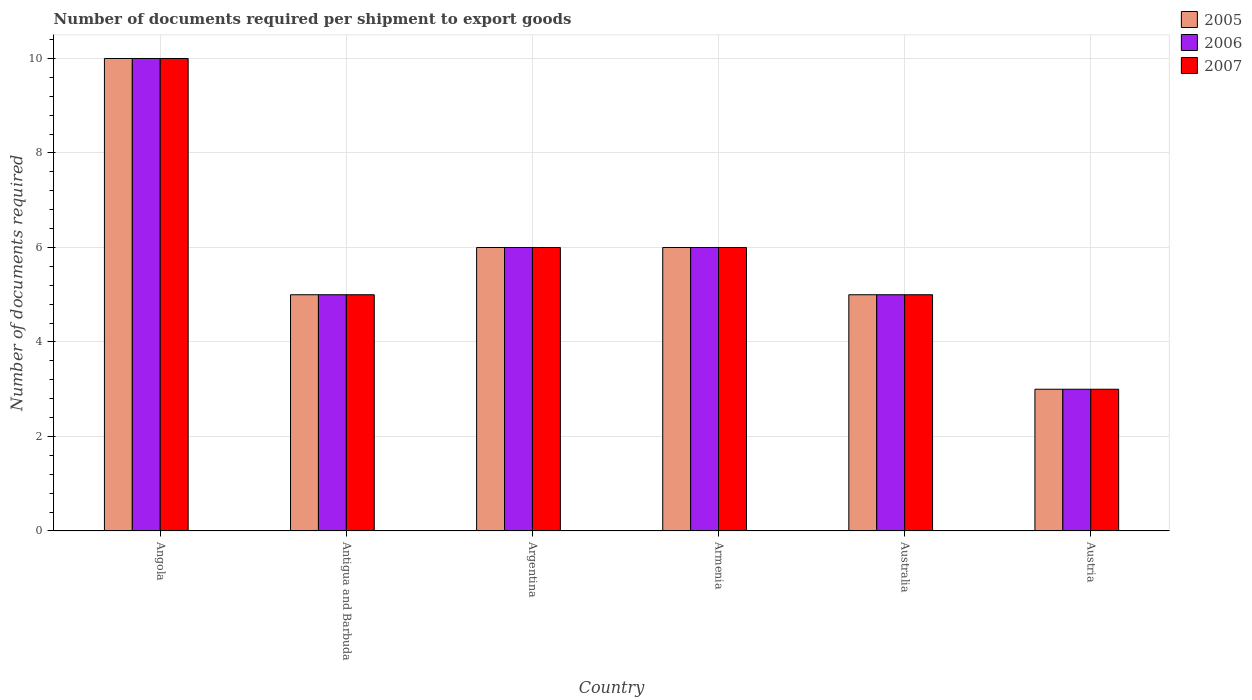How many different coloured bars are there?
Give a very brief answer. 3. How many groups of bars are there?
Keep it short and to the point. 6. Are the number of bars per tick equal to the number of legend labels?
Your answer should be very brief. Yes. What is the number of documents required per shipment to export goods in 2007 in Antigua and Barbuda?
Make the answer very short. 5. Across all countries, what is the maximum number of documents required per shipment to export goods in 2007?
Ensure brevity in your answer.  10. Across all countries, what is the minimum number of documents required per shipment to export goods in 2006?
Keep it short and to the point. 3. In which country was the number of documents required per shipment to export goods in 2006 maximum?
Keep it short and to the point. Angola. What is the average number of documents required per shipment to export goods in 2006 per country?
Ensure brevity in your answer.  5.83. What is the ratio of the number of documents required per shipment to export goods in 2005 in Antigua and Barbuda to that in Austria?
Provide a short and direct response. 1.67. What is the difference between the highest and the second highest number of documents required per shipment to export goods in 2005?
Provide a short and direct response. 4. In how many countries, is the number of documents required per shipment to export goods in 2005 greater than the average number of documents required per shipment to export goods in 2005 taken over all countries?
Your response must be concise. 3. Is the sum of the number of documents required per shipment to export goods in 2007 in Australia and Austria greater than the maximum number of documents required per shipment to export goods in 2005 across all countries?
Your response must be concise. No. What does the 3rd bar from the left in Austria represents?
Your answer should be very brief. 2007. What does the 1st bar from the right in Australia represents?
Your answer should be very brief. 2007. Is it the case that in every country, the sum of the number of documents required per shipment to export goods in 2005 and number of documents required per shipment to export goods in 2007 is greater than the number of documents required per shipment to export goods in 2006?
Offer a very short reply. Yes. How many countries are there in the graph?
Provide a short and direct response. 6. What is the difference between two consecutive major ticks on the Y-axis?
Keep it short and to the point. 2. Does the graph contain any zero values?
Your response must be concise. No. What is the title of the graph?
Offer a very short reply. Number of documents required per shipment to export goods. What is the label or title of the X-axis?
Provide a succinct answer. Country. What is the label or title of the Y-axis?
Your answer should be compact. Number of documents required. What is the Number of documents required of 2007 in Angola?
Provide a short and direct response. 10. What is the Number of documents required in 2005 in Antigua and Barbuda?
Make the answer very short. 5. What is the Number of documents required of 2007 in Antigua and Barbuda?
Your answer should be compact. 5. What is the Number of documents required in 2005 in Argentina?
Make the answer very short. 6. What is the Number of documents required of 2006 in Argentina?
Provide a short and direct response. 6. What is the Number of documents required in 2007 in Argentina?
Make the answer very short. 6. What is the Number of documents required in 2006 in Armenia?
Make the answer very short. 6. What is the Number of documents required of 2007 in Armenia?
Offer a terse response. 6. What is the Number of documents required of 2005 in Australia?
Your response must be concise. 5. What is the Number of documents required of 2007 in Australia?
Give a very brief answer. 5. What is the Number of documents required of 2005 in Austria?
Provide a succinct answer. 3. What is the Number of documents required of 2006 in Austria?
Your answer should be compact. 3. Across all countries, what is the maximum Number of documents required in 2006?
Make the answer very short. 10. Across all countries, what is the minimum Number of documents required in 2007?
Provide a succinct answer. 3. What is the total Number of documents required of 2007 in the graph?
Your response must be concise. 35. What is the difference between the Number of documents required in 2005 in Angola and that in Antigua and Barbuda?
Keep it short and to the point. 5. What is the difference between the Number of documents required of 2006 in Angola and that in Antigua and Barbuda?
Keep it short and to the point. 5. What is the difference between the Number of documents required of 2007 in Angola and that in Antigua and Barbuda?
Your answer should be compact. 5. What is the difference between the Number of documents required of 2005 in Angola and that in Argentina?
Offer a terse response. 4. What is the difference between the Number of documents required in 2006 in Angola and that in Argentina?
Keep it short and to the point. 4. What is the difference between the Number of documents required in 2007 in Angola and that in Armenia?
Provide a short and direct response. 4. What is the difference between the Number of documents required of 2007 in Angola and that in Australia?
Provide a succinct answer. 5. What is the difference between the Number of documents required in 2006 in Angola and that in Austria?
Ensure brevity in your answer.  7. What is the difference between the Number of documents required of 2007 in Angola and that in Austria?
Your answer should be very brief. 7. What is the difference between the Number of documents required in 2006 in Antigua and Barbuda and that in Armenia?
Make the answer very short. -1. What is the difference between the Number of documents required in 2007 in Antigua and Barbuda and that in Armenia?
Give a very brief answer. -1. What is the difference between the Number of documents required of 2005 in Antigua and Barbuda and that in Australia?
Offer a terse response. 0. What is the difference between the Number of documents required in 2007 in Antigua and Barbuda and that in Australia?
Ensure brevity in your answer.  0. What is the difference between the Number of documents required in 2006 in Antigua and Barbuda and that in Austria?
Your answer should be compact. 2. What is the difference between the Number of documents required in 2005 in Argentina and that in Armenia?
Ensure brevity in your answer.  0. What is the difference between the Number of documents required of 2007 in Argentina and that in Armenia?
Give a very brief answer. 0. What is the difference between the Number of documents required in 2006 in Argentina and that in Australia?
Your answer should be very brief. 1. What is the difference between the Number of documents required of 2007 in Argentina and that in Australia?
Your answer should be compact. 1. What is the difference between the Number of documents required in 2005 in Armenia and that in Australia?
Offer a very short reply. 1. What is the difference between the Number of documents required in 2005 in Armenia and that in Austria?
Provide a succinct answer. 3. What is the difference between the Number of documents required in 2007 in Armenia and that in Austria?
Make the answer very short. 3. What is the difference between the Number of documents required in 2005 in Australia and that in Austria?
Offer a terse response. 2. What is the difference between the Number of documents required in 2005 in Angola and the Number of documents required in 2007 in Antigua and Barbuda?
Your response must be concise. 5. What is the difference between the Number of documents required in 2005 in Angola and the Number of documents required in 2006 in Argentina?
Keep it short and to the point. 4. What is the difference between the Number of documents required in 2006 in Angola and the Number of documents required in 2007 in Argentina?
Make the answer very short. 4. What is the difference between the Number of documents required of 2005 in Angola and the Number of documents required of 2006 in Armenia?
Offer a very short reply. 4. What is the difference between the Number of documents required of 2005 in Angola and the Number of documents required of 2007 in Armenia?
Keep it short and to the point. 4. What is the difference between the Number of documents required of 2005 in Angola and the Number of documents required of 2007 in Australia?
Offer a terse response. 5. What is the difference between the Number of documents required in 2005 in Angola and the Number of documents required in 2007 in Austria?
Offer a terse response. 7. What is the difference between the Number of documents required of 2005 in Antigua and Barbuda and the Number of documents required of 2006 in Argentina?
Give a very brief answer. -1. What is the difference between the Number of documents required in 2005 in Antigua and Barbuda and the Number of documents required in 2007 in Argentina?
Provide a succinct answer. -1. What is the difference between the Number of documents required in 2005 in Antigua and Barbuda and the Number of documents required in 2006 in Armenia?
Offer a terse response. -1. What is the difference between the Number of documents required of 2006 in Antigua and Barbuda and the Number of documents required of 2007 in Armenia?
Your response must be concise. -1. What is the difference between the Number of documents required of 2006 in Antigua and Barbuda and the Number of documents required of 2007 in Australia?
Keep it short and to the point. 0. What is the difference between the Number of documents required of 2005 in Antigua and Barbuda and the Number of documents required of 2007 in Austria?
Give a very brief answer. 2. What is the difference between the Number of documents required in 2005 in Argentina and the Number of documents required in 2007 in Armenia?
Ensure brevity in your answer.  0. What is the difference between the Number of documents required in 2006 in Argentina and the Number of documents required in 2007 in Australia?
Your answer should be very brief. 1. What is the difference between the Number of documents required in 2006 in Argentina and the Number of documents required in 2007 in Austria?
Give a very brief answer. 3. What is the difference between the Number of documents required of 2005 in Armenia and the Number of documents required of 2007 in Australia?
Provide a short and direct response. 1. What is the difference between the Number of documents required in 2005 in Armenia and the Number of documents required in 2006 in Austria?
Give a very brief answer. 3. What is the difference between the Number of documents required of 2005 in Armenia and the Number of documents required of 2007 in Austria?
Provide a succinct answer. 3. What is the difference between the Number of documents required in 2006 in Armenia and the Number of documents required in 2007 in Austria?
Make the answer very short. 3. What is the difference between the Number of documents required of 2005 in Australia and the Number of documents required of 2006 in Austria?
Give a very brief answer. 2. What is the difference between the Number of documents required of 2005 in Australia and the Number of documents required of 2007 in Austria?
Provide a short and direct response. 2. What is the average Number of documents required in 2005 per country?
Make the answer very short. 5.83. What is the average Number of documents required in 2006 per country?
Keep it short and to the point. 5.83. What is the average Number of documents required in 2007 per country?
Keep it short and to the point. 5.83. What is the difference between the Number of documents required in 2005 and Number of documents required in 2006 in Angola?
Offer a very short reply. 0. What is the difference between the Number of documents required in 2006 and Number of documents required in 2007 in Angola?
Your response must be concise. 0. What is the difference between the Number of documents required in 2005 and Number of documents required in 2006 in Antigua and Barbuda?
Your response must be concise. 0. What is the difference between the Number of documents required of 2005 and Number of documents required of 2007 in Antigua and Barbuda?
Provide a succinct answer. 0. What is the difference between the Number of documents required of 2006 and Number of documents required of 2007 in Antigua and Barbuda?
Make the answer very short. 0. What is the difference between the Number of documents required of 2005 and Number of documents required of 2006 in Argentina?
Keep it short and to the point. 0. What is the difference between the Number of documents required of 2005 and Number of documents required of 2007 in Argentina?
Your response must be concise. 0. What is the difference between the Number of documents required in 2005 and Number of documents required in 2007 in Armenia?
Your answer should be very brief. 0. What is the difference between the Number of documents required of 2005 and Number of documents required of 2007 in Australia?
Give a very brief answer. 0. What is the ratio of the Number of documents required of 2006 in Angola to that in Antigua and Barbuda?
Ensure brevity in your answer.  2. What is the ratio of the Number of documents required in 2007 in Angola to that in Argentina?
Your response must be concise. 1.67. What is the ratio of the Number of documents required in 2007 in Angola to that in Armenia?
Keep it short and to the point. 1.67. What is the ratio of the Number of documents required of 2005 in Angola to that in Australia?
Ensure brevity in your answer.  2. What is the ratio of the Number of documents required in 2007 in Angola to that in Australia?
Your response must be concise. 2. What is the ratio of the Number of documents required in 2006 in Angola to that in Austria?
Your answer should be compact. 3.33. What is the ratio of the Number of documents required in 2005 in Antigua and Barbuda to that in Argentina?
Your response must be concise. 0.83. What is the ratio of the Number of documents required in 2007 in Antigua and Barbuda to that in Argentina?
Offer a terse response. 0.83. What is the ratio of the Number of documents required of 2006 in Antigua and Barbuda to that in Armenia?
Your answer should be very brief. 0.83. What is the ratio of the Number of documents required of 2007 in Antigua and Barbuda to that in Armenia?
Provide a short and direct response. 0.83. What is the ratio of the Number of documents required of 2007 in Antigua and Barbuda to that in Australia?
Provide a short and direct response. 1. What is the ratio of the Number of documents required of 2005 in Antigua and Barbuda to that in Austria?
Provide a succinct answer. 1.67. What is the ratio of the Number of documents required of 2006 in Antigua and Barbuda to that in Austria?
Offer a terse response. 1.67. What is the ratio of the Number of documents required in 2005 in Argentina to that in Armenia?
Make the answer very short. 1. What is the ratio of the Number of documents required of 2007 in Argentina to that in Australia?
Your response must be concise. 1.2. What is the ratio of the Number of documents required in 2005 in Argentina to that in Austria?
Provide a short and direct response. 2. What is the ratio of the Number of documents required of 2006 in Argentina to that in Austria?
Your answer should be very brief. 2. What is the ratio of the Number of documents required in 2007 in Armenia to that in Australia?
Provide a succinct answer. 1.2. What is the ratio of the Number of documents required of 2007 in Armenia to that in Austria?
Offer a terse response. 2. What is the difference between the highest and the second highest Number of documents required in 2007?
Provide a short and direct response. 4. What is the difference between the highest and the lowest Number of documents required in 2006?
Give a very brief answer. 7. What is the difference between the highest and the lowest Number of documents required of 2007?
Your answer should be compact. 7. 